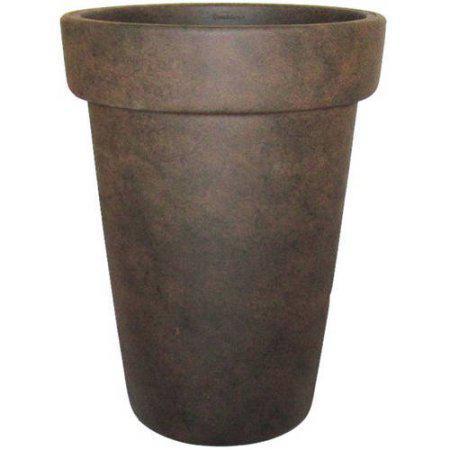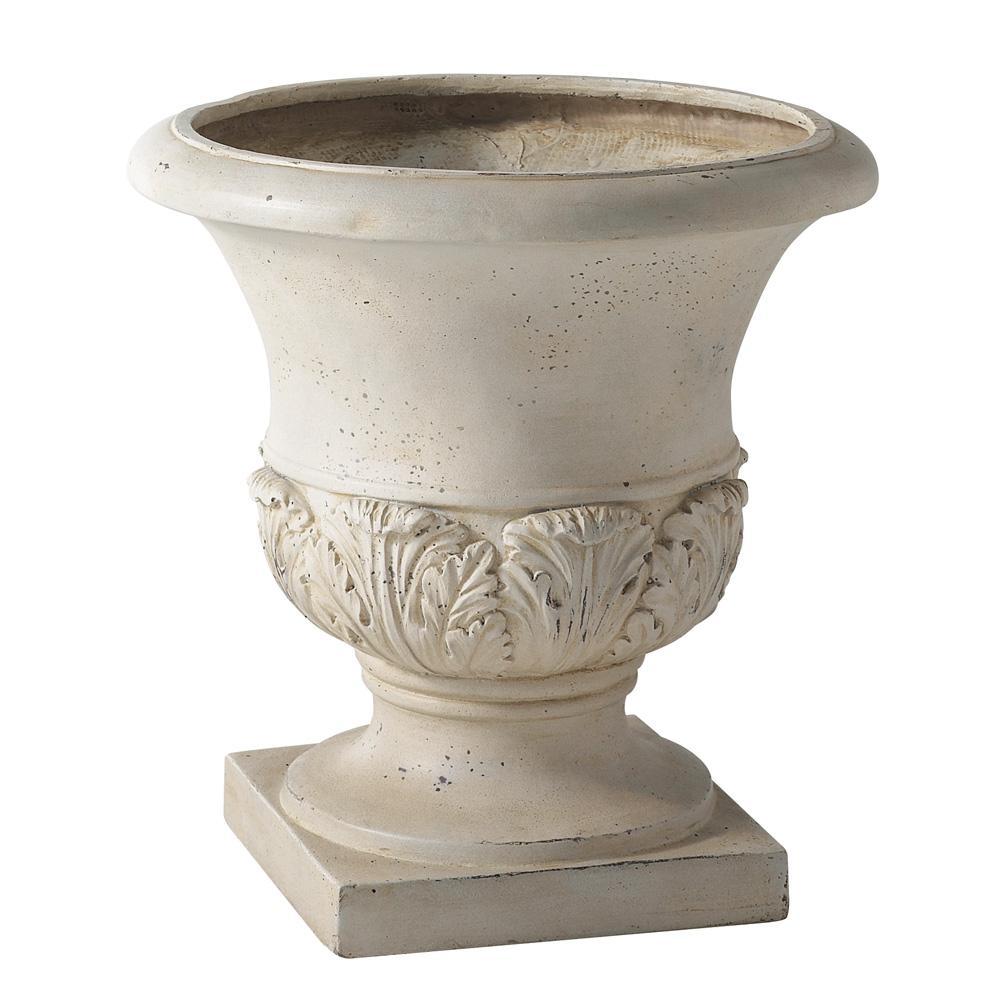The first image is the image on the left, the second image is the image on the right. Considering the images on both sides, is "Each image contains one empty urn, and one of the urn models is footed, with a pedestal base." valid? Answer yes or no. Yes. The first image is the image on the left, the second image is the image on the right. For the images shown, is this caption "In one image, a flowering plant is shown in a tall planter pot outside" true? Answer yes or no. No. 